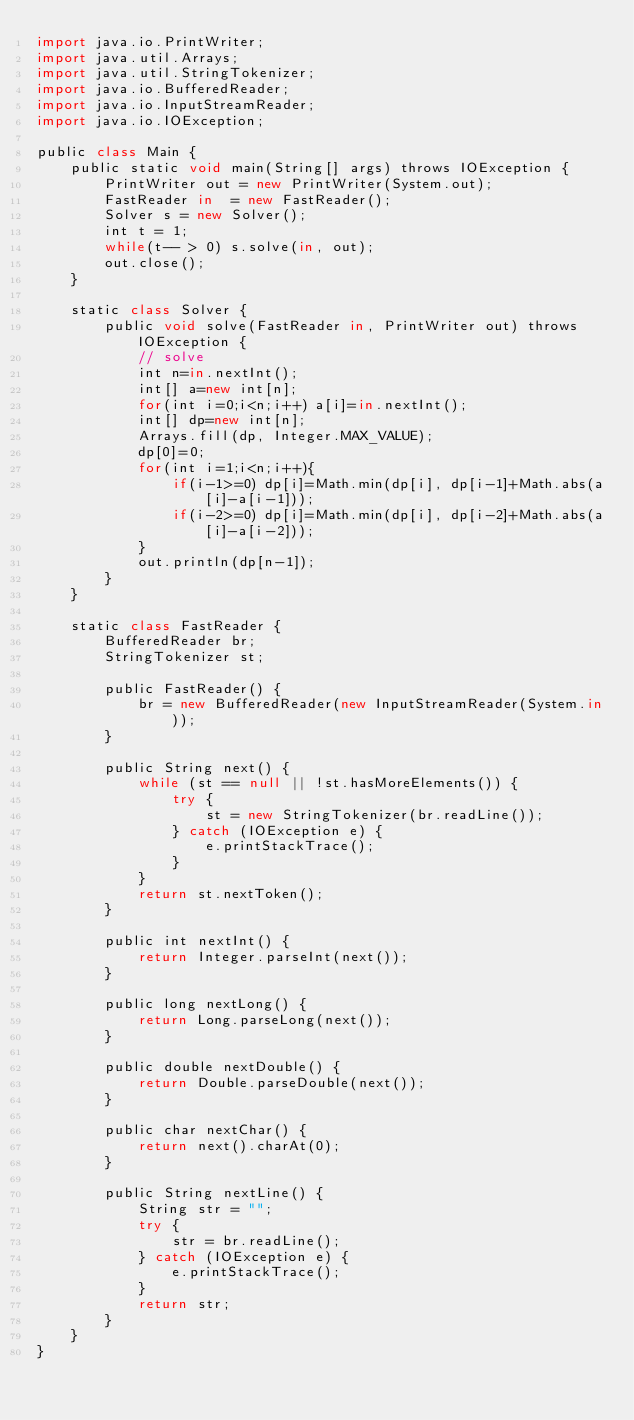<code> <loc_0><loc_0><loc_500><loc_500><_JavaScript_>import java.io.PrintWriter;
import java.util.Arrays;
import java.util.StringTokenizer;
import java.io.BufferedReader;
import java.io.InputStreamReader;
import java.io.IOException;

public class Main {
    public static void main(String[] args) throws IOException {
        PrintWriter out = new PrintWriter(System.out);
        FastReader in  = new FastReader(); 
        Solver s = new Solver();
        int t = 1;
        while(t-- > 0) s.solve(in, out);
        out.close();
    }

    static class Solver {
        public void solve(FastReader in, PrintWriter out) throws IOException {
            // solve
            int n=in.nextInt();
            int[] a=new int[n];
            for(int i=0;i<n;i++) a[i]=in.nextInt();
            int[] dp=new int[n];
            Arrays.fill(dp, Integer.MAX_VALUE);
            dp[0]=0;
            for(int i=1;i<n;i++){
                if(i-1>=0) dp[i]=Math.min(dp[i], dp[i-1]+Math.abs(a[i]-a[i-1]));
                if(i-2>=0) dp[i]=Math.min(dp[i], dp[i-2]+Math.abs(a[i]-a[i-2]));
            }
            out.println(dp[n-1]);
        } 
    }

    static class FastReader {
        BufferedReader br;
        StringTokenizer st;

        public FastReader() {
            br = new BufferedReader(new InputStreamReader(System.in));
        }

        public String next() {
            while (st == null || !st.hasMoreElements()) {
                try {
                    st = new StringTokenizer(br.readLine());
                } catch (IOException e) {
                    e.printStackTrace();
                }
            }
            return st.nextToken();
        }

        public int nextInt() {
            return Integer.parseInt(next());
        }

        public long nextLong() {
            return Long.parseLong(next());
        }

        public double nextDouble() {
            return Double.parseDouble(next());
        }

        public char nextChar() {
            return next().charAt(0);
        }

        public String nextLine() {
            String str = "";
            try {
                str = br.readLine();
            } catch (IOException e) {
                e.printStackTrace();
            }
            return str;
        }
    }
}</code> 